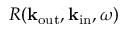<formula> <loc_0><loc_0><loc_500><loc_500>R ( k _ { o u t } , k _ { i n } , \omega )</formula> 